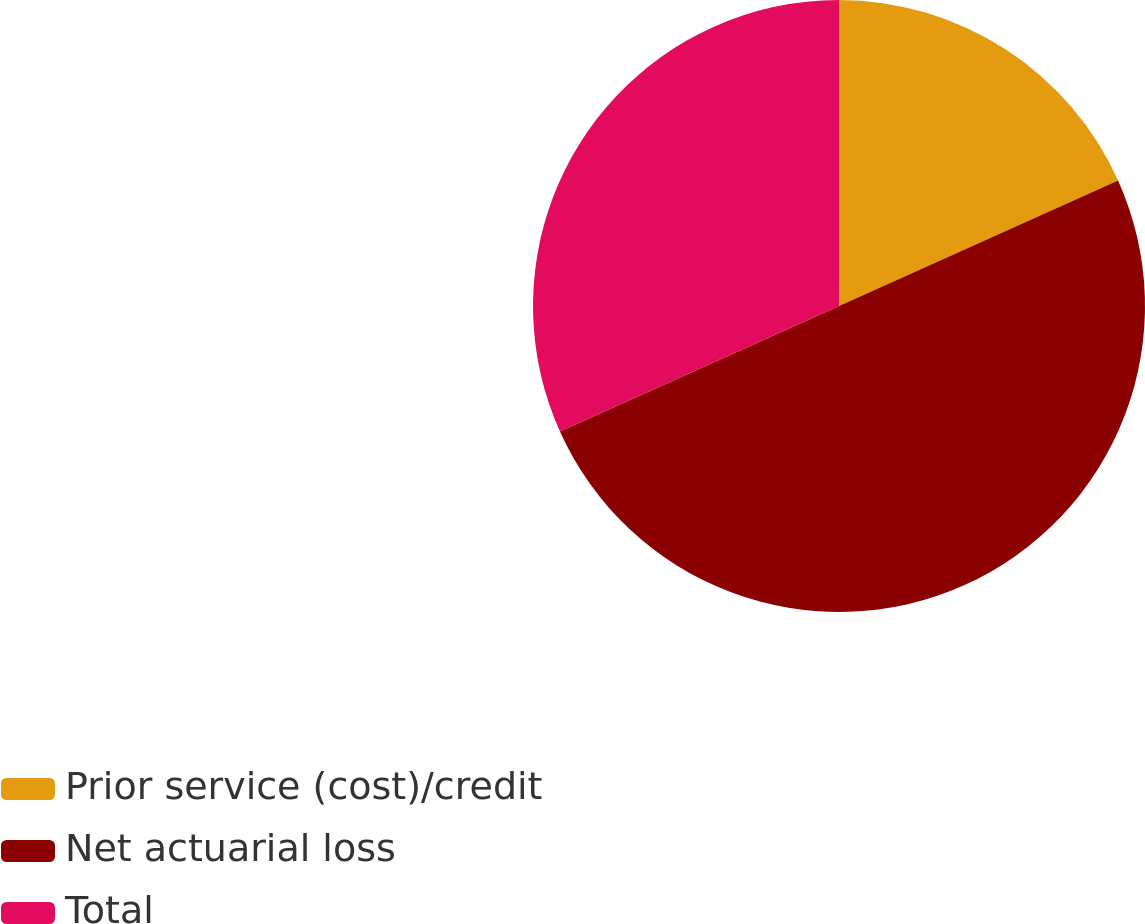<chart> <loc_0><loc_0><loc_500><loc_500><pie_chart><fcel>Prior service (cost)/credit<fcel>Net actuarial loss<fcel>Total<nl><fcel>18.27%<fcel>50.0%<fcel>31.73%<nl></chart> 